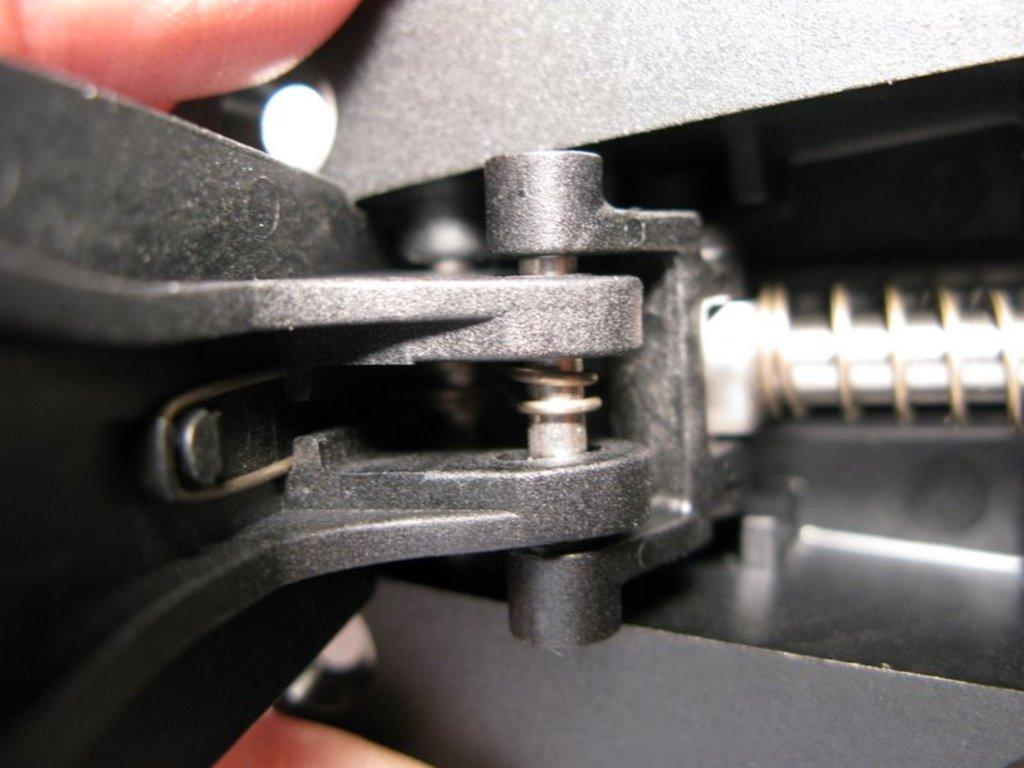What is the color of the object in the image? The object in the image is black. Can you describe any other elements in the image? A human hand is visible in the image. What type of plot is being discussed in the image? There is no plot or discussion present in the image; it only features a black object and a human hand. 